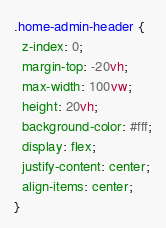Convert code to text. <code><loc_0><loc_0><loc_500><loc_500><_CSS_>.home-admin-header {
  z-index: 0;
  margin-top: -20vh;
  max-width: 100vw;
  height: 20vh;
  background-color: #fff;
  display: flex;
  justify-content: center;
  align-items: center;
}

</code> 